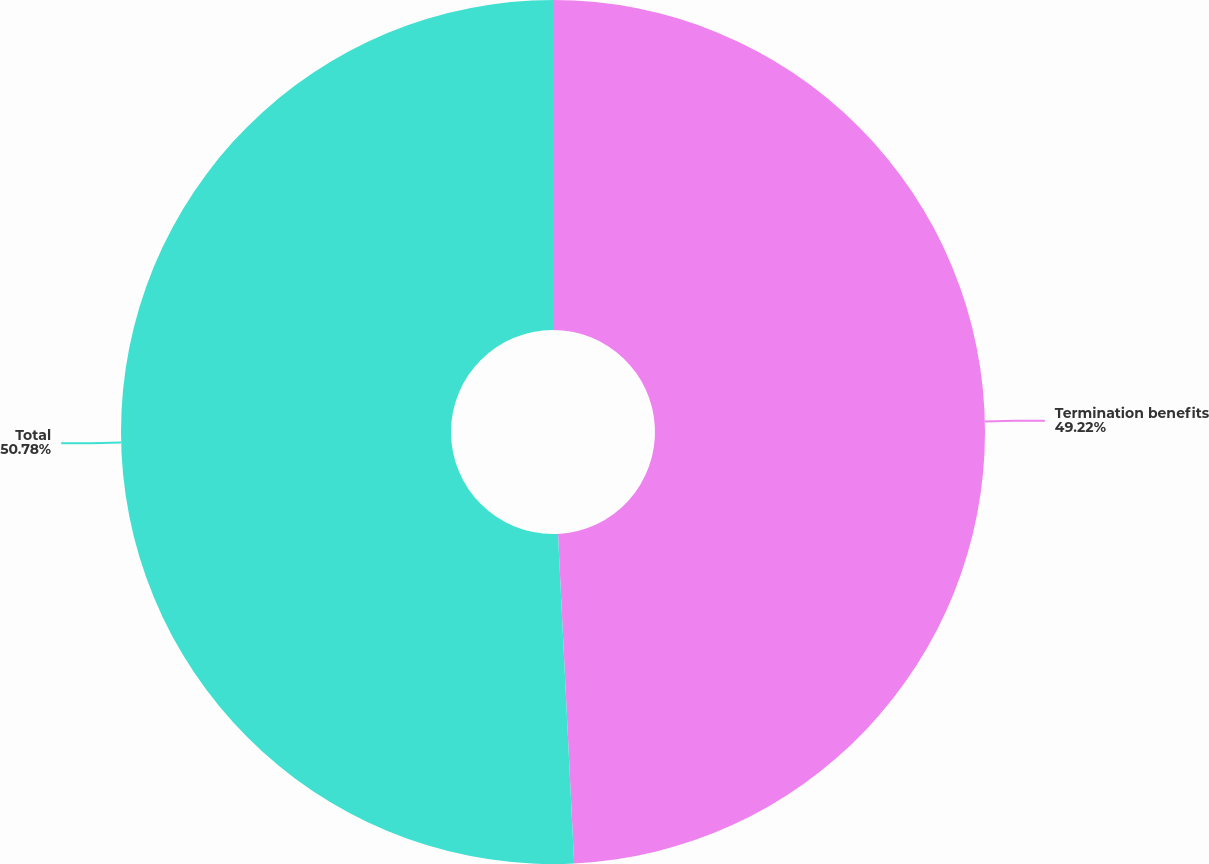Convert chart to OTSL. <chart><loc_0><loc_0><loc_500><loc_500><pie_chart><fcel>Termination benefits<fcel>Total<nl><fcel>49.22%<fcel>50.78%<nl></chart> 